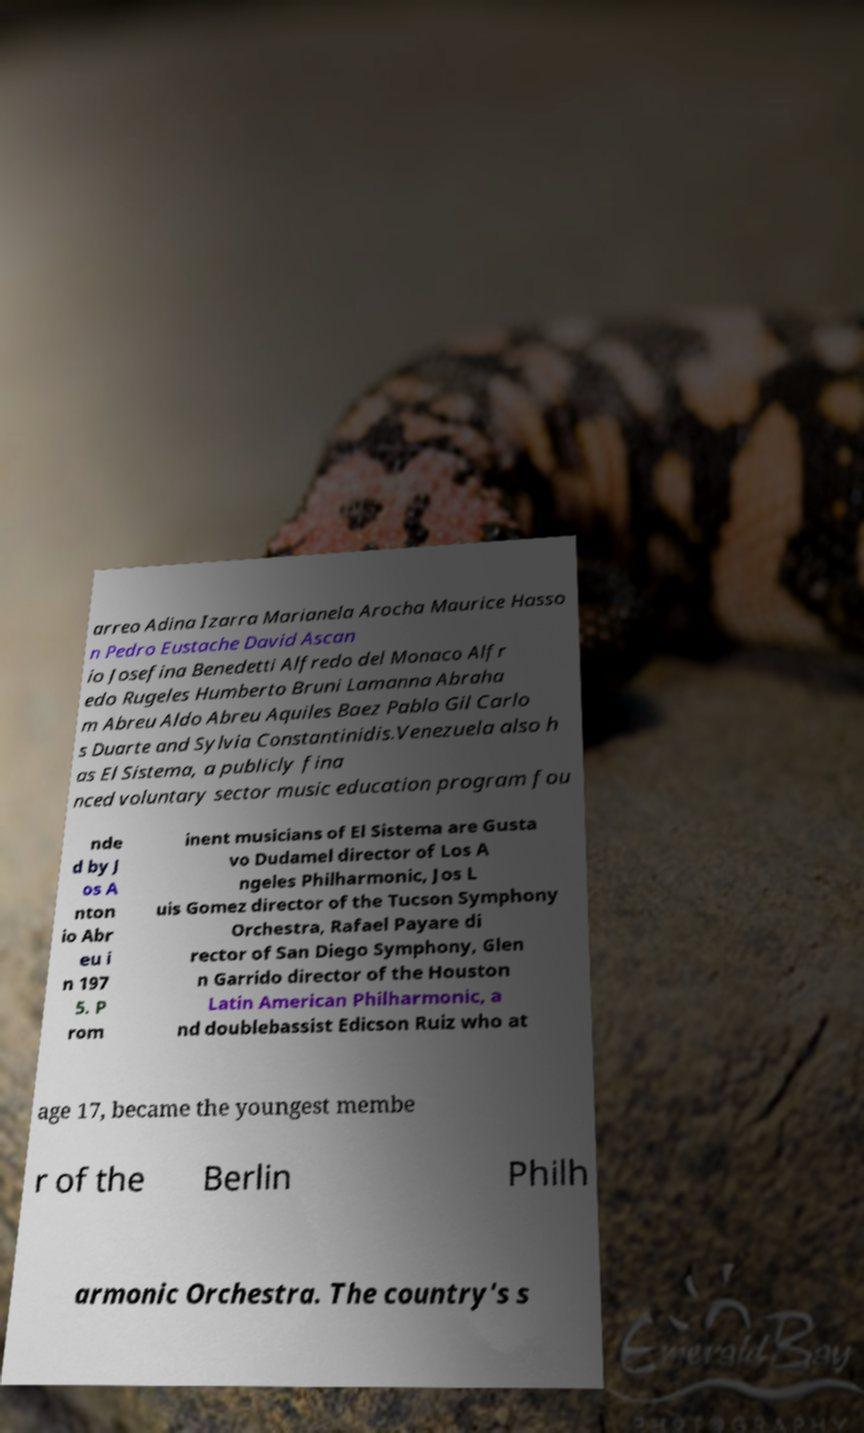I need the written content from this picture converted into text. Can you do that? arreo Adina Izarra Marianela Arocha Maurice Hasso n Pedro Eustache David Ascan io Josefina Benedetti Alfredo del Monaco Alfr edo Rugeles Humberto Bruni Lamanna Abraha m Abreu Aldo Abreu Aquiles Baez Pablo Gil Carlo s Duarte and Sylvia Constantinidis.Venezuela also h as El Sistema, a publicly fina nced voluntary sector music education program fou nde d by J os A nton io Abr eu i n 197 5. P rom inent musicians of El Sistema are Gusta vo Dudamel director of Los A ngeles Philharmonic, Jos L uis Gomez director of the Tucson Symphony Orchestra, Rafael Payare di rector of San Diego Symphony, Glen n Garrido director of the Houston Latin American Philharmonic, a nd doublebassist Edicson Ruiz who at age 17, became the youngest membe r of the Berlin Philh armonic Orchestra. The country's s 